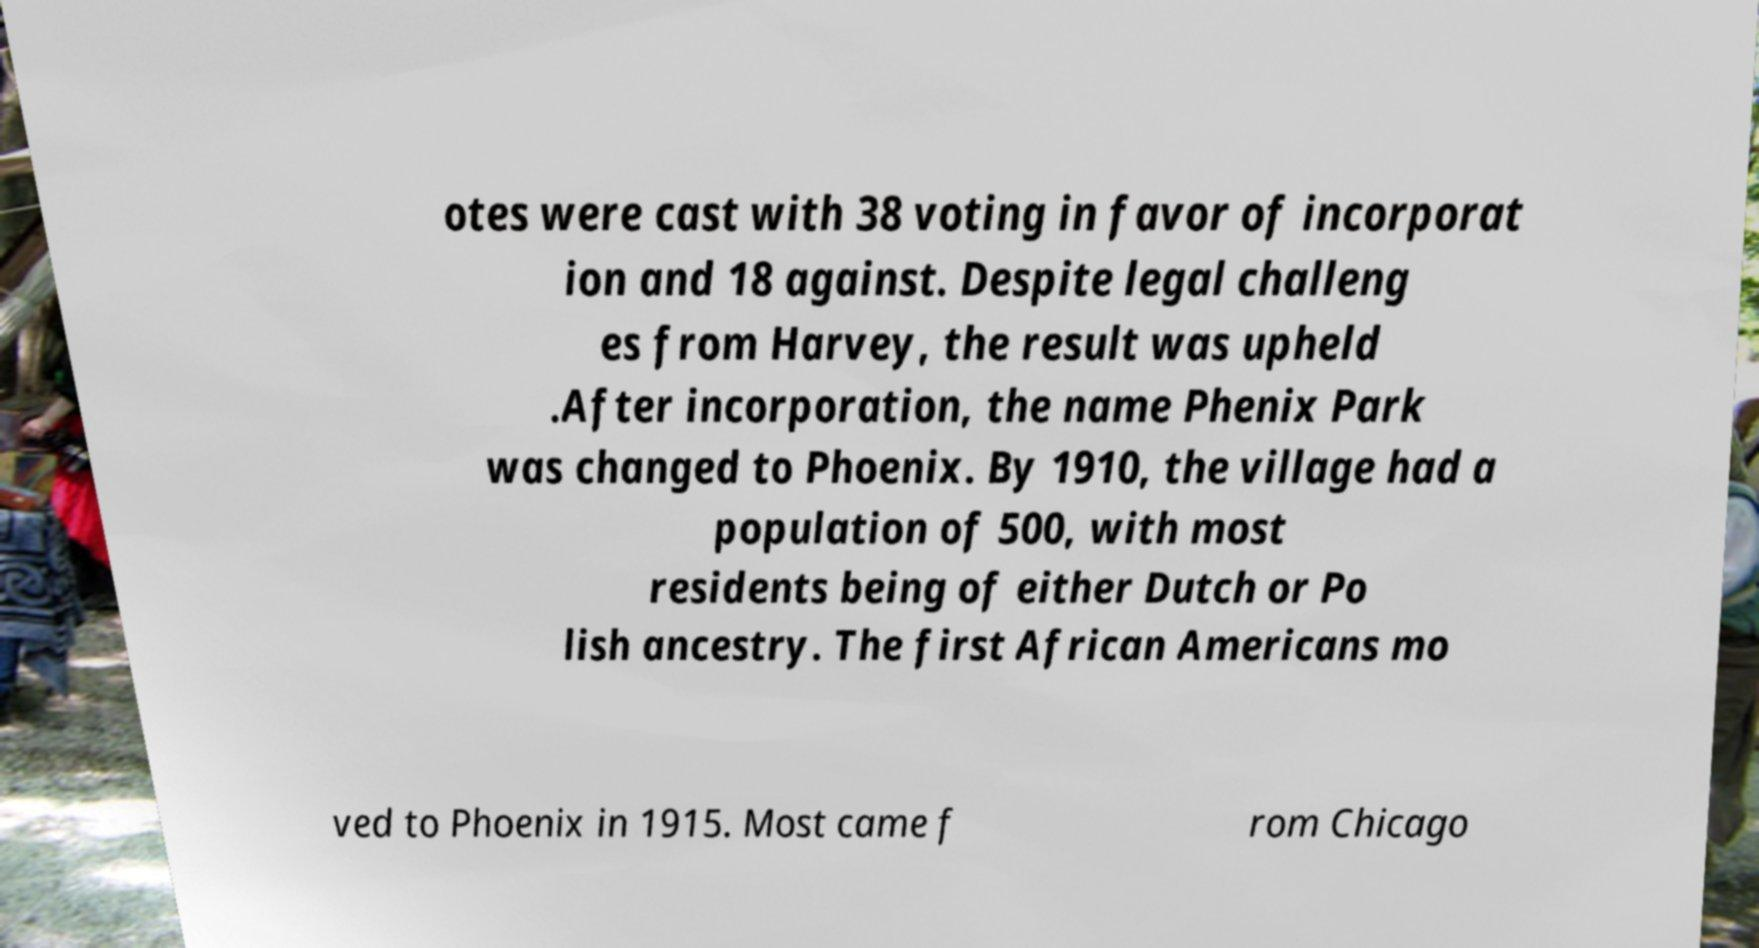Please identify and transcribe the text found in this image. otes were cast with 38 voting in favor of incorporat ion and 18 against. Despite legal challeng es from Harvey, the result was upheld .After incorporation, the name Phenix Park was changed to Phoenix. By 1910, the village had a population of 500, with most residents being of either Dutch or Po lish ancestry. The first African Americans mo ved to Phoenix in 1915. Most came f rom Chicago 